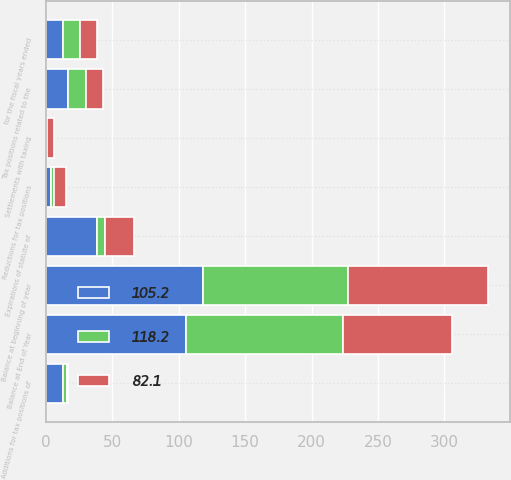Convert chart. <chart><loc_0><loc_0><loc_500><loc_500><stacked_bar_chart><ecel><fcel>for the fiscal years ended<fcel>Balance at beginning of year<fcel>Additions for tax positions of<fcel>Reductions for tax positions<fcel>Tax positions related to the<fcel>Settlements with taxing<fcel>Expirations of statute of<fcel>Balance at End of Year<nl><fcel>82.1<fcel>12.9<fcel>105.2<fcel>0.6<fcel>9<fcel>12.9<fcel>5.4<fcel>22.2<fcel>82.1<nl><fcel>105.2<fcel>12.9<fcel>118.2<fcel>12.6<fcel>3.4<fcel>16.2<fcel>0.1<fcel>38.3<fcel>105.2<nl><fcel>118.2<fcel>12.9<fcel>109.5<fcel>3<fcel>2.4<fcel>14.1<fcel>0.3<fcel>5.7<fcel>118.2<nl></chart> 